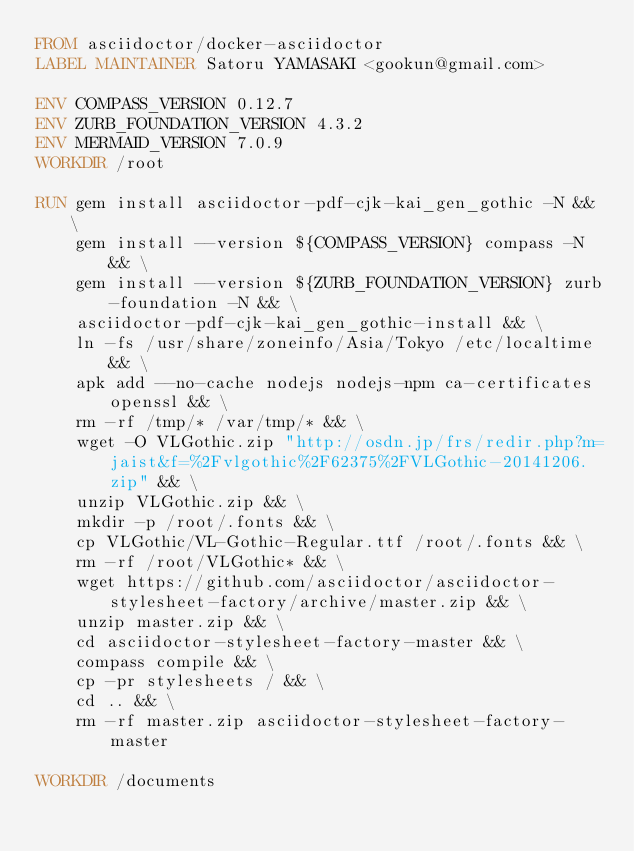Convert code to text. <code><loc_0><loc_0><loc_500><loc_500><_Dockerfile_>FROM asciidoctor/docker-asciidoctor
LABEL MAINTAINER Satoru YAMASAKI <gookun@gmail.com>

ENV COMPASS_VERSION 0.12.7
ENV ZURB_FOUNDATION_VERSION 4.3.2
ENV MERMAID_VERSION 7.0.9
WORKDIR /root

RUN gem install asciidoctor-pdf-cjk-kai_gen_gothic -N && \
    gem install --version ${COMPASS_VERSION} compass -N && \
    gem install --version ${ZURB_FOUNDATION_VERSION} zurb-foundation -N && \
    asciidoctor-pdf-cjk-kai_gen_gothic-install && \
    ln -fs /usr/share/zoneinfo/Asia/Tokyo /etc/localtime && \
    apk add --no-cache nodejs nodejs-npm ca-certificates openssl && \
    rm -rf /tmp/* /var/tmp/* && \
    wget -O VLGothic.zip "http://osdn.jp/frs/redir.php?m=jaist&f=%2Fvlgothic%2F62375%2FVLGothic-20141206.zip" && \
    unzip VLGothic.zip && \
    mkdir -p /root/.fonts && \
    cp VLGothic/VL-Gothic-Regular.ttf /root/.fonts && \
    rm -rf /root/VLGothic* && \
    wget https://github.com/asciidoctor/asciidoctor-stylesheet-factory/archive/master.zip && \
    unzip master.zip && \
    cd asciidoctor-stylesheet-factory-master && \
    compass compile && \
    cp -pr stylesheets / && \
    cd .. && \
    rm -rf master.zip asciidoctor-stylesheet-factory-master
   
WORKDIR /documents
</code> 